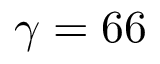<formula> <loc_0><loc_0><loc_500><loc_500>\gamma = 6 6</formula> 